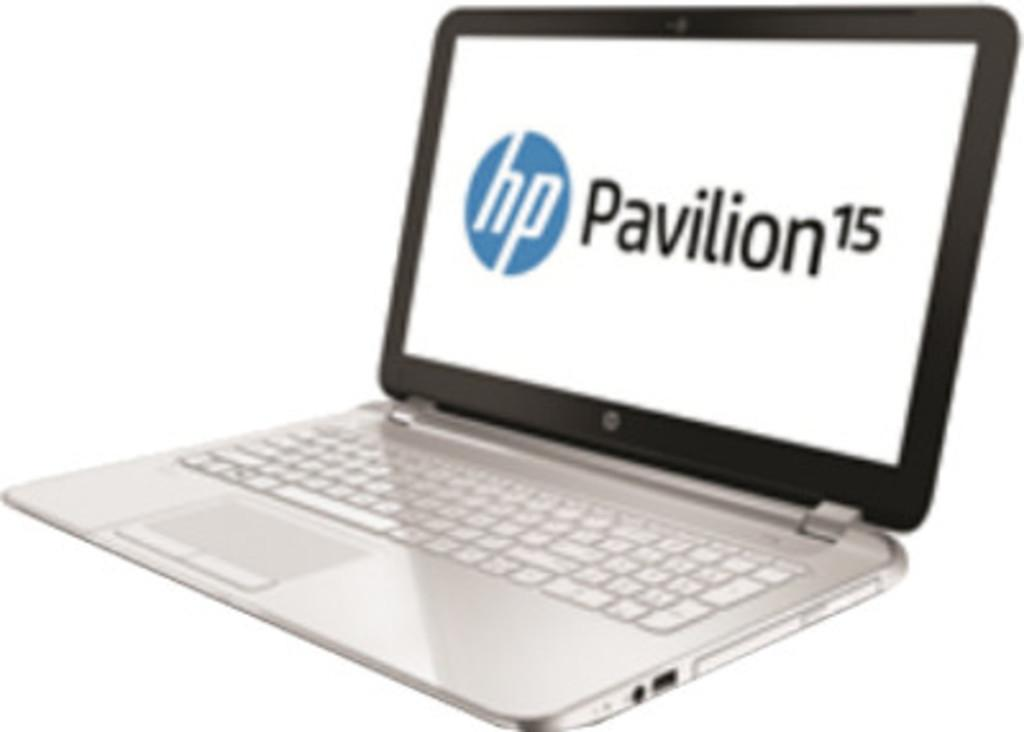Provide a one-sentence caption for the provided image. A HP Pavilion laptop sits on a white background. 